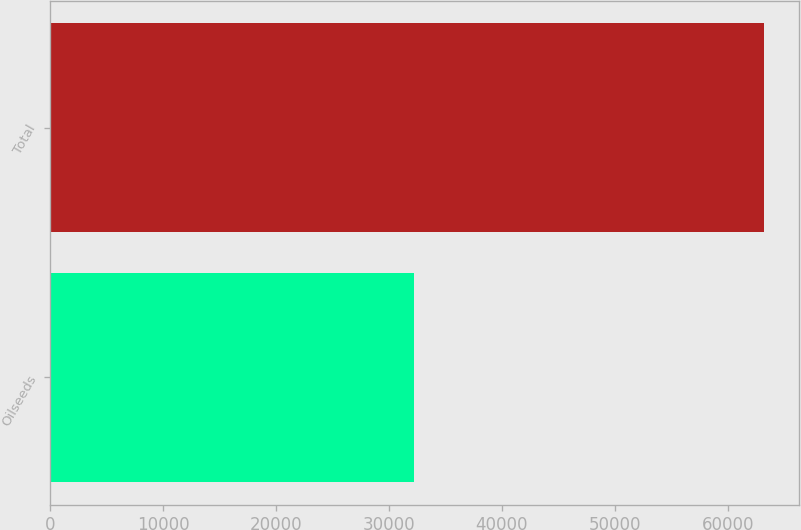Convert chart to OTSL. <chart><loc_0><loc_0><loc_500><loc_500><bar_chart><fcel>Oilseeds<fcel>Total<nl><fcel>32208<fcel>63194<nl></chart> 